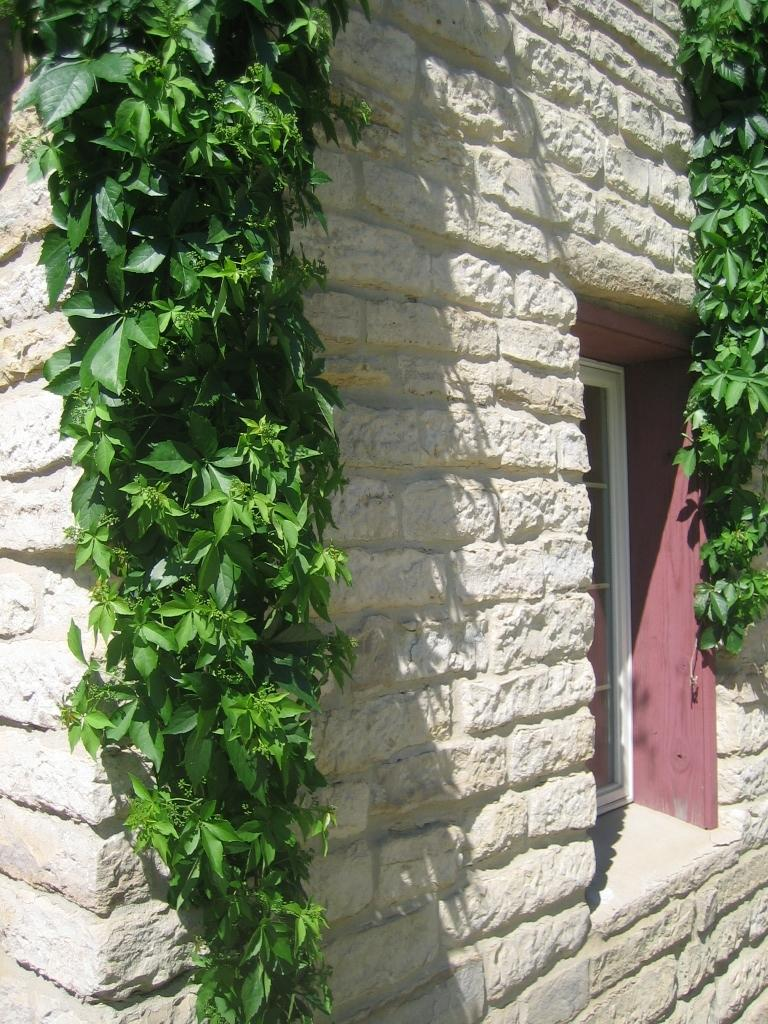What type of vegetation can be seen in the image? There are creepers in the image. What type of structure is present in the image? There is a stone wall in the image. What type of windows are visible in the image? There are glass windows in the image. What is the color and material of the frame in the image? There is a maroon color wooden frame in the image. What is the weight of the pear hanging from the wooden frame in the image? There is no pear present in the image, and therefore no weight can be determined. What type of wool is used to make the creepers in the image? The creepers in the image are not made of wool; they are a type of vegetation. 